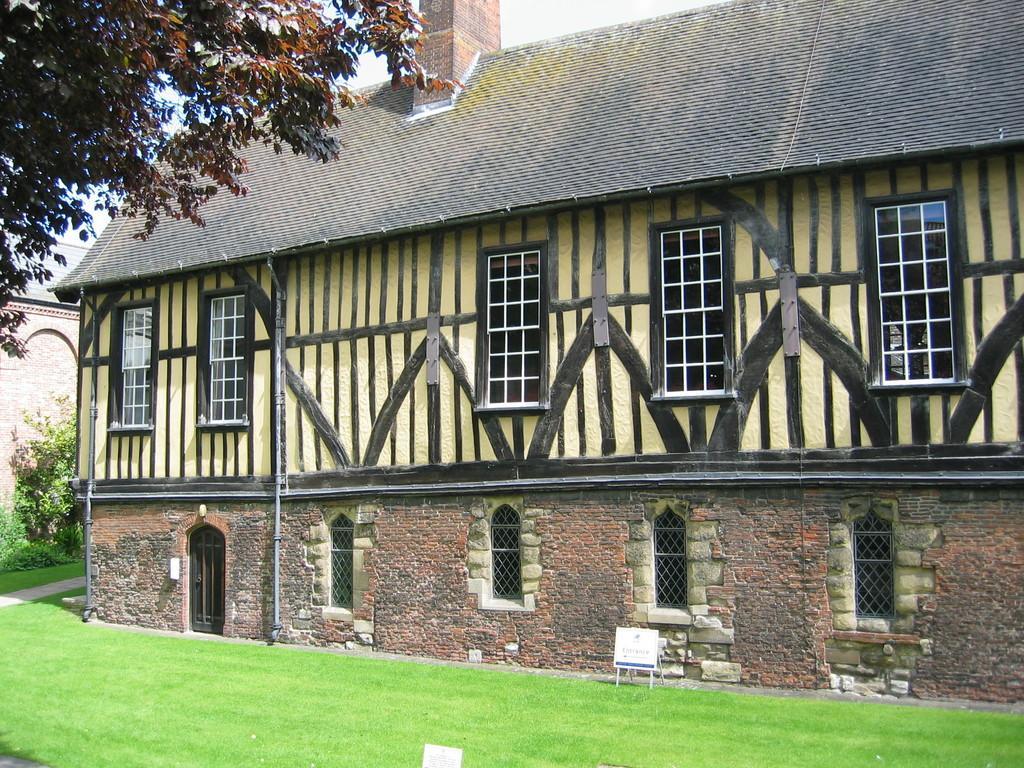In one or two sentences, can you explain what this image depicts? This image consists of buildings, windows, grass, border, plants, trees and the sky. This image is taken may be during a day. 